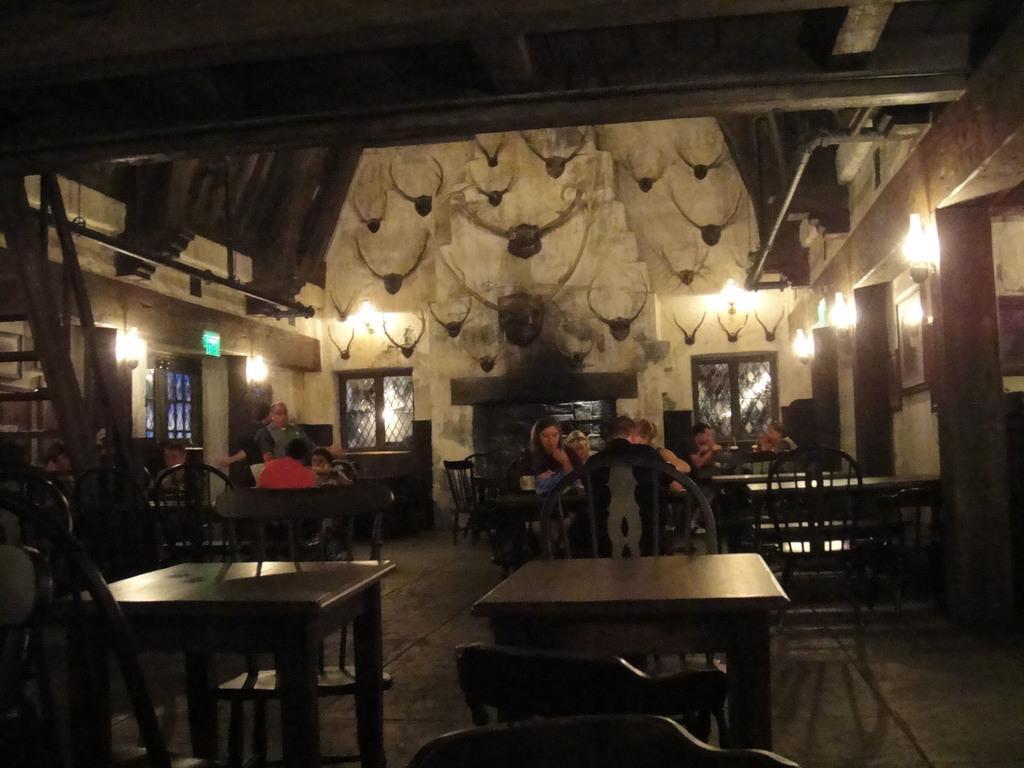How would you summarize this image in a sentence or two? In this image I can see the table with chairs. At the back side there are group of people sitting in front of the table and two people are standing. In the image I can also see the lights and the windows. 